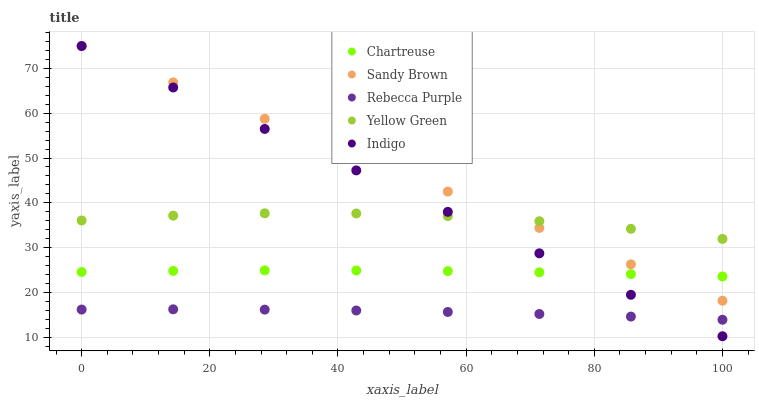Does Rebecca Purple have the minimum area under the curve?
Answer yes or no. Yes. Does Sandy Brown have the maximum area under the curve?
Answer yes or no. Yes. Does Chartreuse have the minimum area under the curve?
Answer yes or no. No. Does Chartreuse have the maximum area under the curve?
Answer yes or no. No. Is Sandy Brown the smoothest?
Answer yes or no. Yes. Is Yellow Green the roughest?
Answer yes or no. Yes. Is Chartreuse the smoothest?
Answer yes or no. No. Is Chartreuse the roughest?
Answer yes or no. No. Does Indigo have the lowest value?
Answer yes or no. Yes. Does Chartreuse have the lowest value?
Answer yes or no. No. Does Sandy Brown have the highest value?
Answer yes or no. Yes. Does Chartreuse have the highest value?
Answer yes or no. No. Is Rebecca Purple less than Yellow Green?
Answer yes or no. Yes. Is Yellow Green greater than Rebecca Purple?
Answer yes or no. Yes. Does Sandy Brown intersect Chartreuse?
Answer yes or no. Yes. Is Sandy Brown less than Chartreuse?
Answer yes or no. No. Is Sandy Brown greater than Chartreuse?
Answer yes or no. No. Does Rebecca Purple intersect Yellow Green?
Answer yes or no. No. 